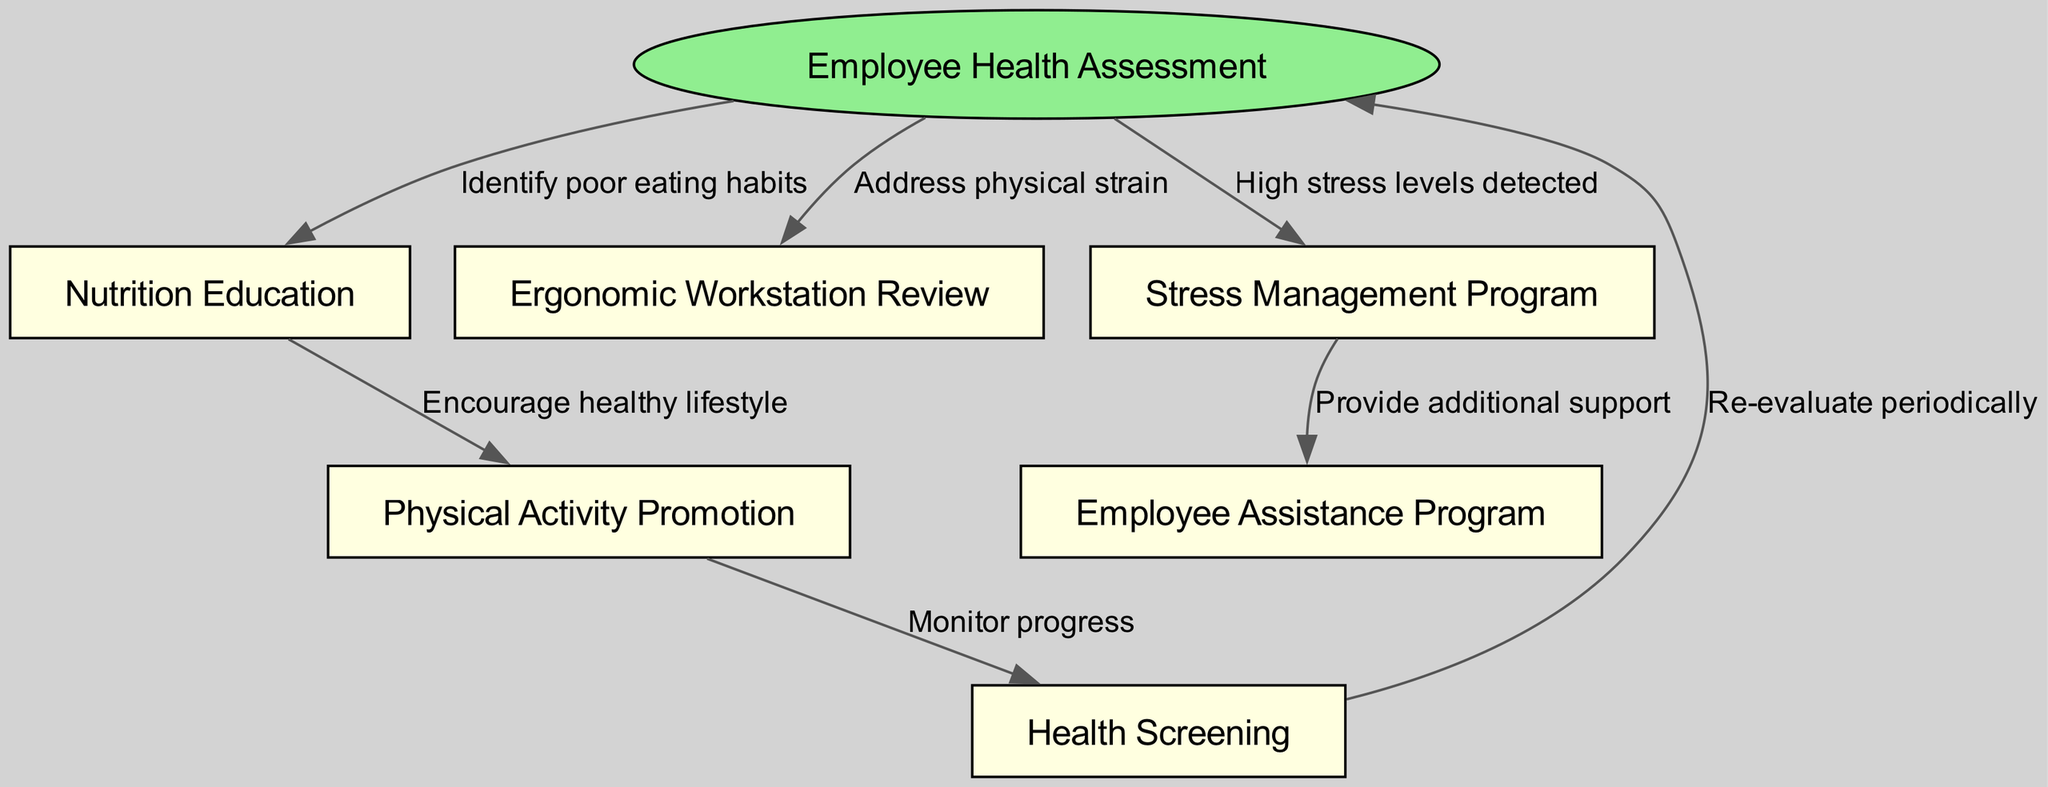What is the starting point of the clinical pathway? The starting point of the clinical pathway is represented by the "Employee Health Assessment" node. This is identified as the first node in the diagram where the process begins.
Answer: Employee Health Assessment How many nodes are present in the diagram? To count the nodes, we consider the starting node along with all other nodes connected to it. There are a total of 6 nodes: "Employee Health Assessment," "Nutrition Education," "Ergonomic Workstation Review," "Stress Management Program," "Physical Activity Promotion," and "Health Screening."
Answer: 6 What is the label for the edge from "Employee Health Assessment" to "Nutrition Education"? The label indicates the reason for the connection between these two nodes and specifically states "Identify poor eating habits" as the purpose of this edge.
Answer: Identify poor eating habits Which program is connected to both "Stress Management Program" and "Health Screening"? Looking at the edges leading out from both nodes, the "Employee Assistance Program" is a direct output of the "Stress Management Program." Additionally, "Health Screening" does not connect back to "Stress Management Program" but can be reached from "Physical Activity Promotion." Thus, the "Employee Assistance Program" is the common program related to stress management.
Answer: Employee Assistance Program If an employee has poor eating habits, which follow-up program should be initiated? The initial assessment would point to "Nutrition Education" to address the identified poor eating habits of the employee based on the directed flow from "Employee Health Assessment." Therefore, the follow-up program is the direct next step.
Answer: Nutrition Education What is the outcome after the "Physical Activity Promotion"? The outcome that directly follows "Physical Activity Promotion" is "Health Screening," indicating that after encouraging physical activity, the next logical step is to monitor progress via health screenings.
Answer: Health Screening What connection is made when high stress levels are detected? When high stress levels are detected, the clinical pathway leads to the "Stress Management Program," where additional support is provided through subsequent connections indicating necessary actions to assist the affected employees.
Answer: Stress Management Program How often should the "Health Screening" be re-evaluated? Based on the diagram, after the "Health Screening" node, there is a directed edge returning to "Employee Health Assessment," suggesting a periodic re-evaluation. While the specific timeframe is not stated, the nature of the question implies a suggestion for regular intervals, typically considered "periodically."
Answer: Periodically What is the final support option available following the "Stress Management Program"? After the "Stress Management Program," the next connected node is the "Employee Assistance Program," which indicates the provision of additional support for employees who may need it.
Answer: Employee Assistance Program 